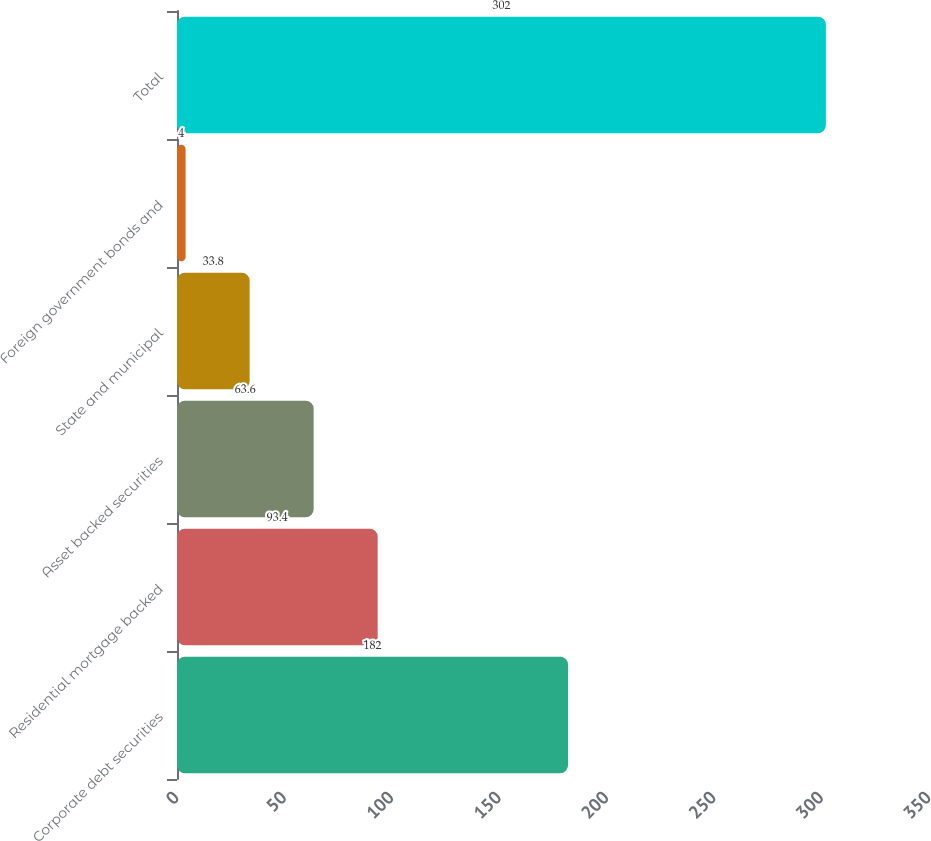Convert chart to OTSL. <chart><loc_0><loc_0><loc_500><loc_500><bar_chart><fcel>Corporate debt securities<fcel>Residential mortgage backed<fcel>Asset backed securities<fcel>State and municipal<fcel>Foreign government bonds and<fcel>Total<nl><fcel>182<fcel>93.4<fcel>63.6<fcel>33.8<fcel>4<fcel>302<nl></chart> 